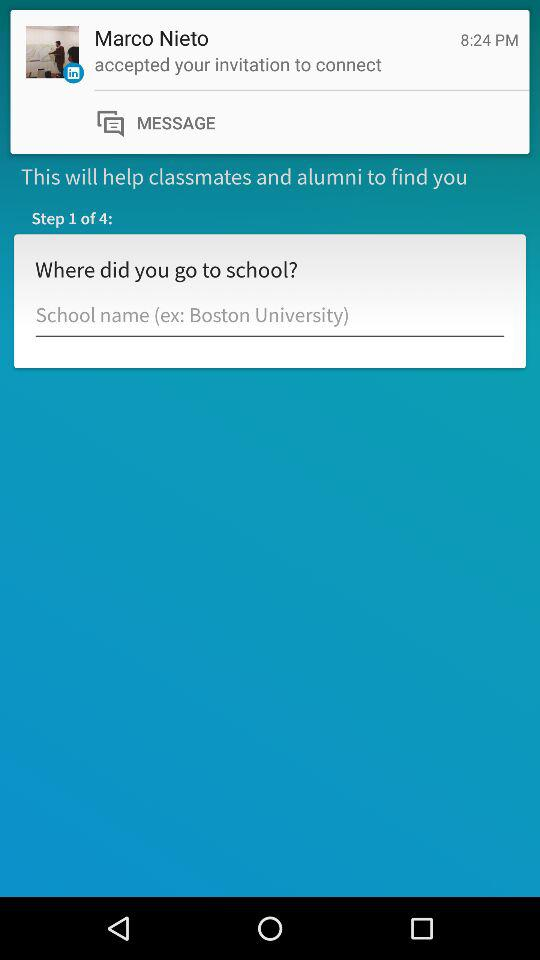What is the given profile name? The given profile name is Marco Nieto. 